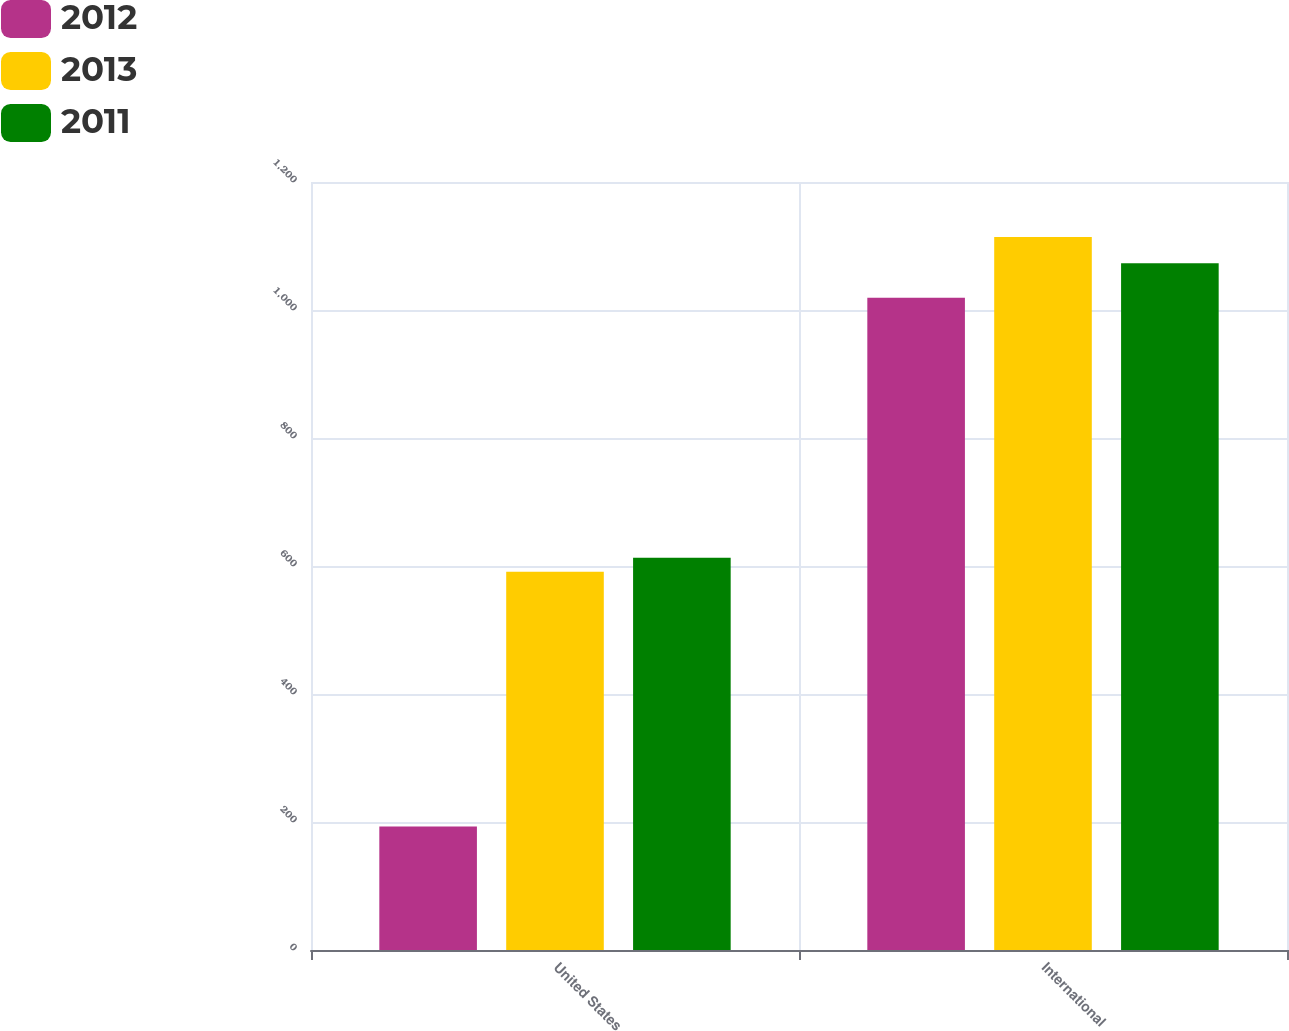<chart> <loc_0><loc_0><loc_500><loc_500><stacked_bar_chart><ecel><fcel>United States<fcel>International<nl><fcel>2012<fcel>193<fcel>1019<nl><fcel>2013<fcel>591<fcel>1114<nl><fcel>2011<fcel>613<fcel>1073<nl></chart> 